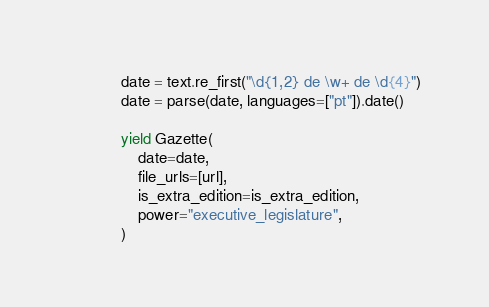Convert code to text. <code><loc_0><loc_0><loc_500><loc_500><_Python_>            date = text.re_first("\d{1,2} de \w+ de \d{4}")
            date = parse(date, languages=["pt"]).date()

            yield Gazette(
                date=date,
                file_urls=[url],
                is_extra_edition=is_extra_edition,
                power="executive_legislature",
            )
</code> 